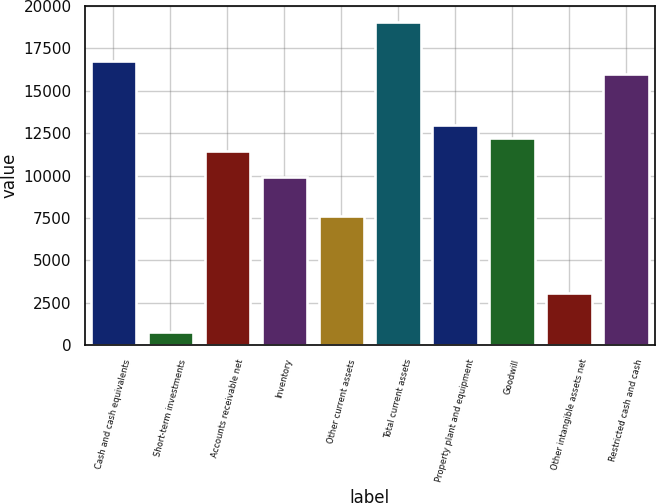Convert chart. <chart><loc_0><loc_0><loc_500><loc_500><bar_chart><fcel>Cash and cash equivalents<fcel>Short-term investments<fcel>Accounts receivable net<fcel>Inventory<fcel>Other current assets<fcel>Total current assets<fcel>Property plant and equipment<fcel>Goodwill<fcel>Other intangible assets net<fcel>Restricted cash and cash<nl><fcel>16772.2<fcel>768.1<fcel>11437.5<fcel>9913.3<fcel>7627<fcel>19058.5<fcel>12961.7<fcel>12199.6<fcel>3054.4<fcel>16010.1<nl></chart> 